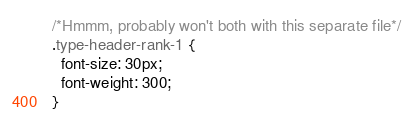<code> <loc_0><loc_0><loc_500><loc_500><_CSS_>/*Hmmm, probably won't both with this separate file*/
.type-header-rank-1 {
  font-size: 30px;
  font-weight: 300;
}
</code> 